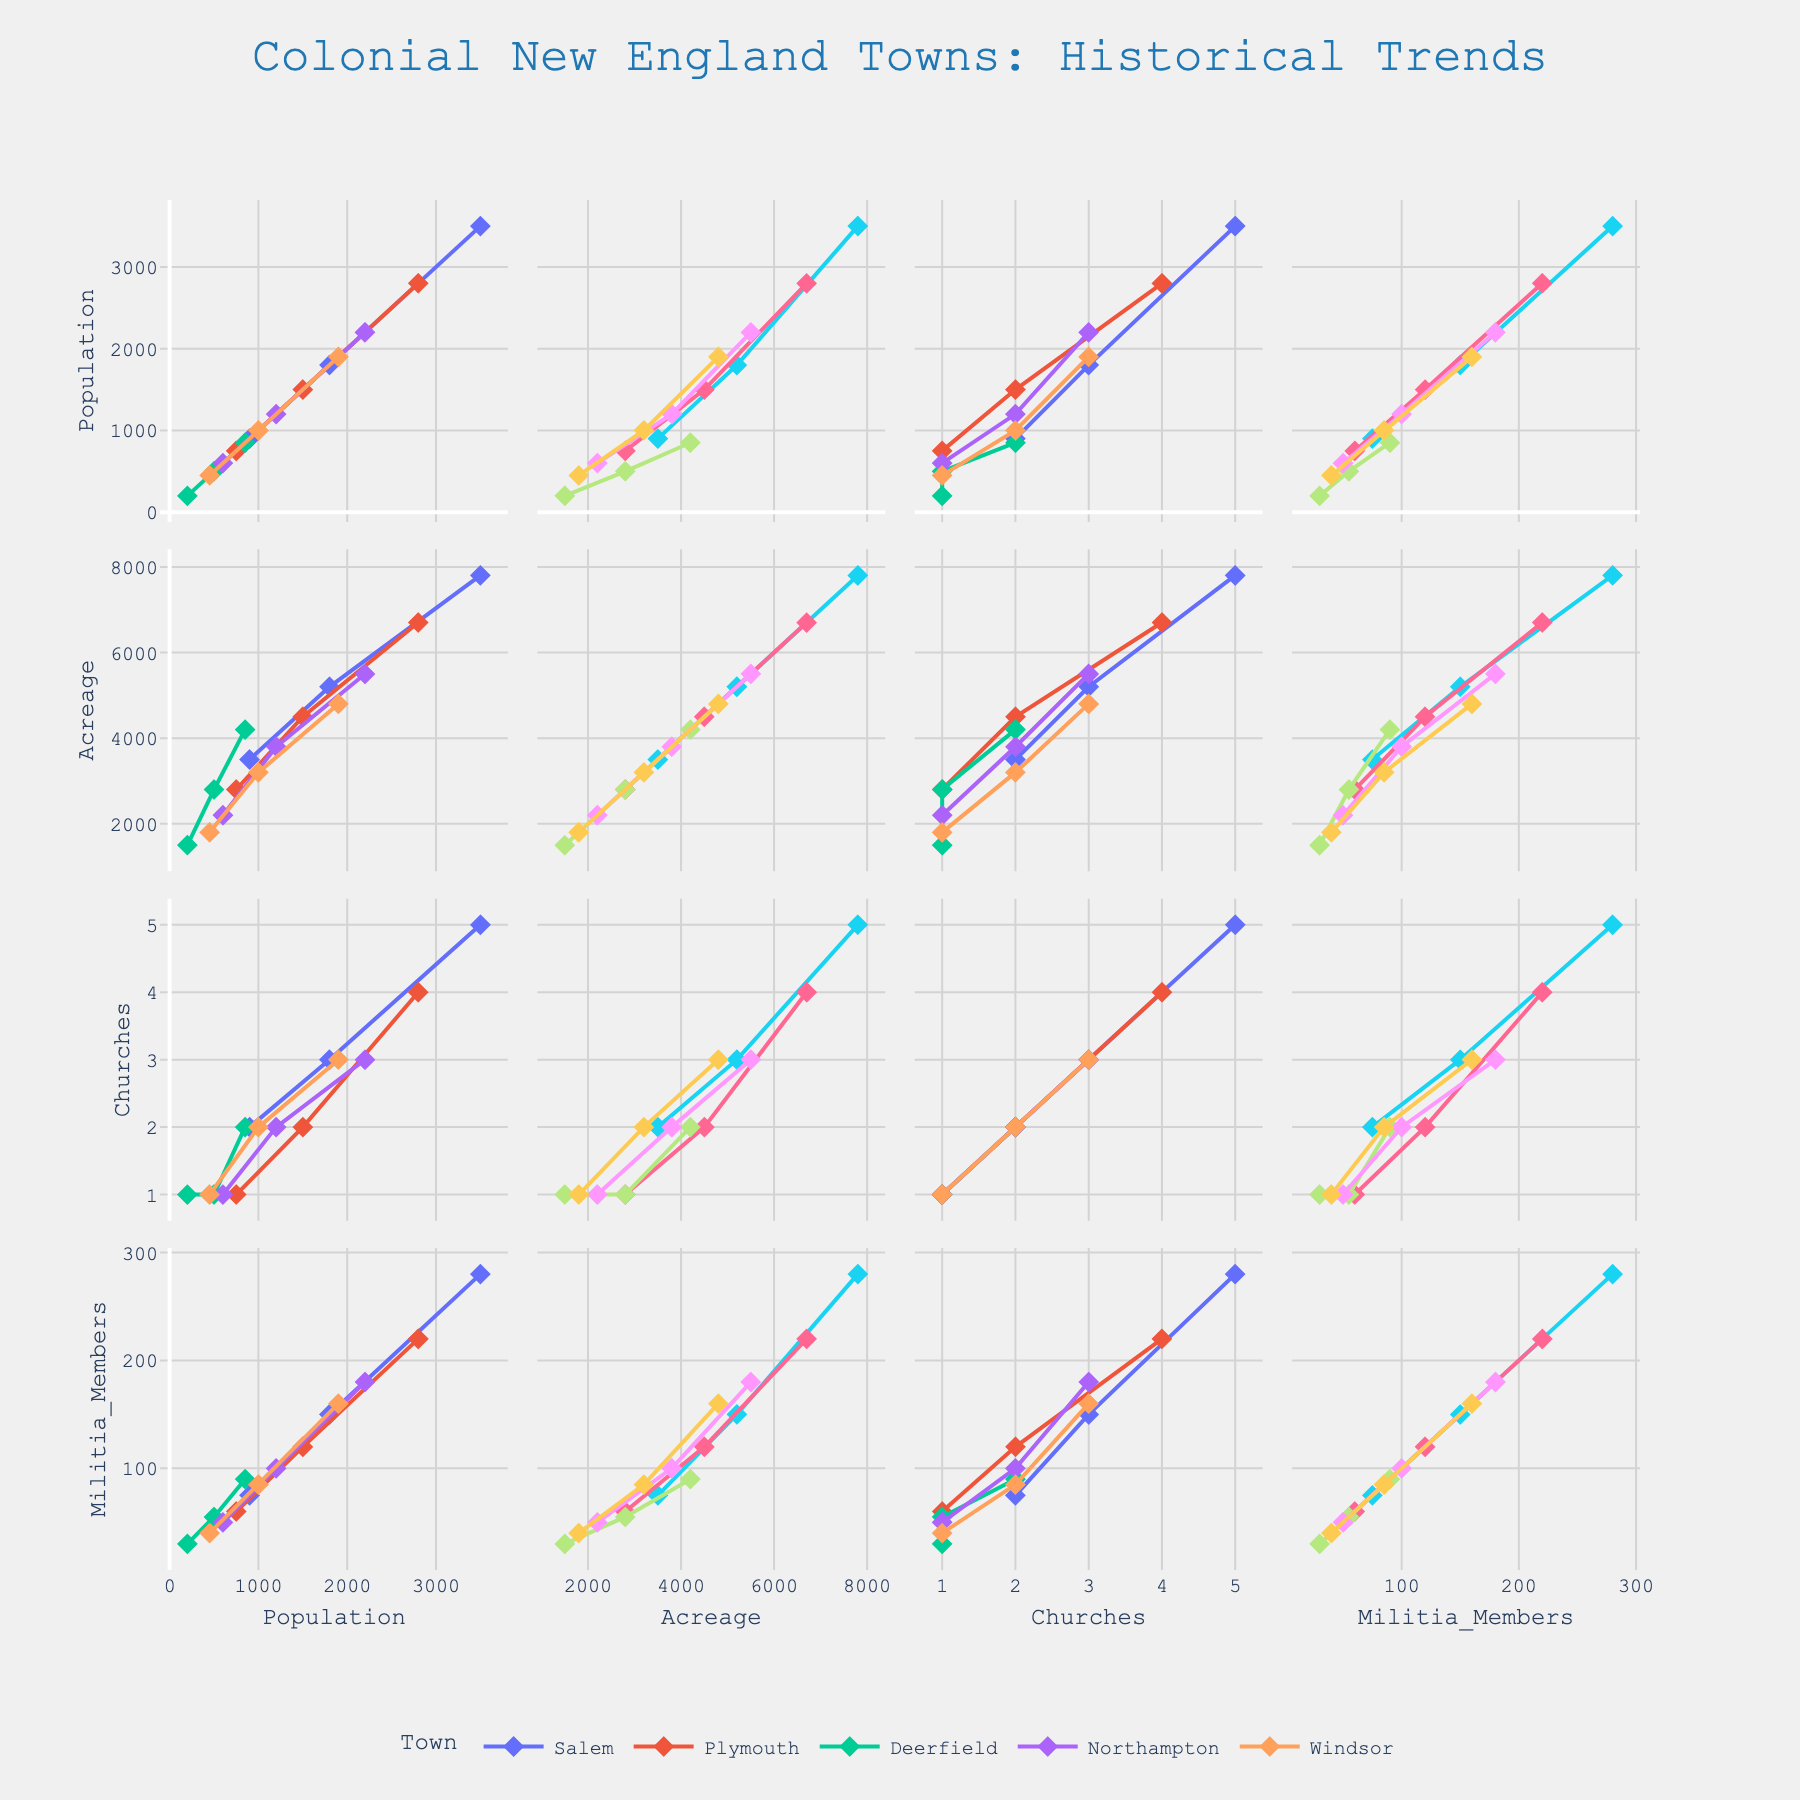Which store has the highest number of customers aged 31-50? By comparing the "Customer Count" for the age group "31-50" across all three stores, it's clear that 99 Ranch Market has the highest number with 320 customers.
Answer: 99 Ranch Market What is the average basket size for Japanese customers aged 31-50? The average basket size for Japanese customers aged 31-50 can be directly read from the figure depicting H Mart, and it is 75.
Answer: 75 Which ethnicity has the smallest average basket size at Great Wall Supermarket? By comparing the average basket sizes for each ethnicity at Great Wall Supermarket, Vietnamese customers have the smallest average basket size of 40.
Answer: Vietnamese How many unique ethnic groups are represented in the figure? The figure includes the ethnicities: Chinese, Vietnamese, Korean, Japanese, and Filipino, totaling to 5 unique ethnic groups.
Answer: 5 For which age group do Korean customers at H Mart have the highest average basket size? Looking at the average basket sizes for Korean customers at different age groups in H Mart, the 31-50 age group has the highest average basket size of 85.
Answer: 31-50 Compare the customer count of Filipino customers aged 31-50 at 99 Ranch Market with Vietnamese customers aged 31-50 at Great Wall Supermarket. Which is higher? The customer count for Filipino customers aged 31-50 at 99 Ranch Market is 100, while for Vietnamese customers aged 31-50 at Great Wall Supermarket it is 110. Therefore, Great Wall Supermarket has the higher count.
Answer: Vietnamese customers at Great Wall Supermarket Which store serves more customers aged 18-30, 99 Ranch Market or H Mart? Comparing the customer counts for the age group 18-30, 99 Ranch Market serves 180 (Chinese) + 60 (Filipino) = 240 customers, while H Mart serves 130 (Korean) + 50 (Japanese) = 180 customers. Thus, 99 Ranch Market serves more.
Answer: 99 Ranch Market What's the total number of Chinese customers across all age groups at Great Wall Supermarket? Summing up the customer counts for Chinese customers at Great Wall Supermarket: 150 (18-30) + 280 (31-50) + 190 (51+) = 620.
Answer: 620 